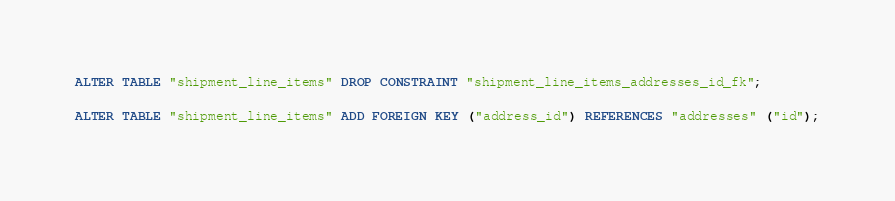Convert code to text. <code><loc_0><loc_0><loc_500><loc_500><_SQL_>ALTER TABLE "shipment_line_items" DROP CONSTRAINT "shipment_line_items_addresses_id_fk";

ALTER TABLE "shipment_line_items" ADD FOREIGN KEY ("address_id") REFERENCES "addresses" ("id");</code> 